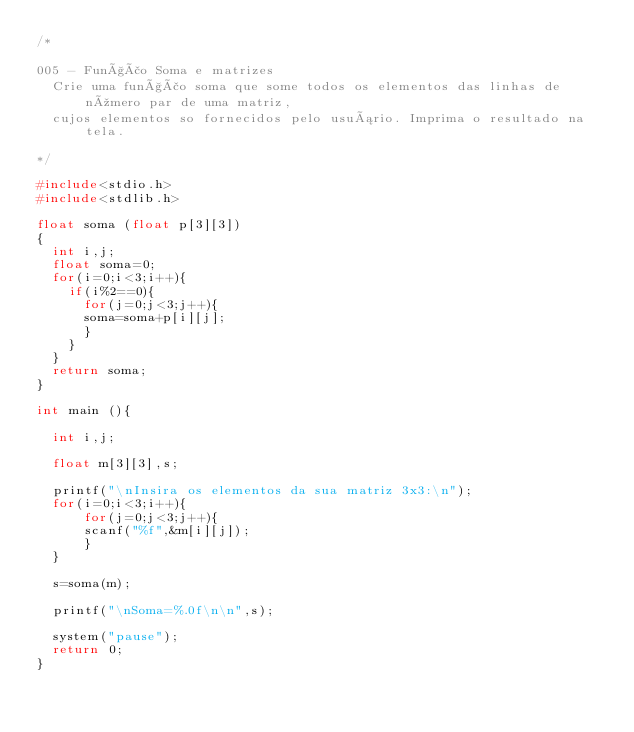Convert code to text. <code><loc_0><loc_0><loc_500><loc_500><_C++_>/*

005 - Função Soma e matrizes
  Crie uma função soma que some todos os elementos das linhas de número par de uma matriz,
  cujos elementos so fornecidos pelo usuário. Imprima o resultado na tela.
  
*/

#include<stdio.h>
#include<stdlib.h>

float soma (float p[3][3])
{
	int i,j;
	float soma=0;
	for(i=0;i<3;i++){
		if(i%2==0){
			for(j=0;j<3;j++){
			soma=soma+p[i][j];
			}
		}
	}
	return soma;
}

int main (){
  
	int i,j;
  
	float m[3][3],s;
  
	printf("\nInsira os elementos da sua matriz 3x3:\n");
	for(i=0;i<3;i++){
			for(j=0;j<3;j++){
			scanf("%f",&m[i][j]);
			}
	}
  
	s=soma(m);
  
	printf("\nSoma=%.0f\n\n",s);
  
	system("pause");
	return 0;
}
</code> 